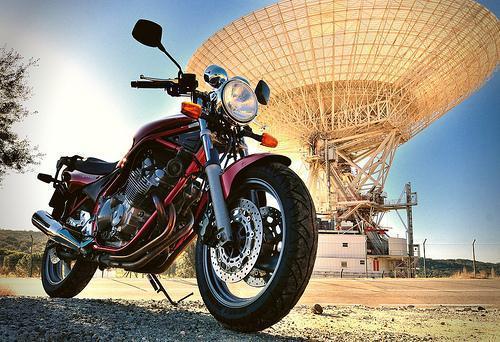How many motorcycles are in the photo?
Give a very brief answer. 1. 